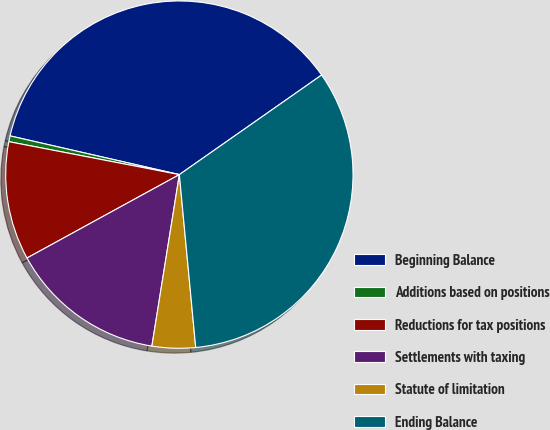Convert chart to OTSL. <chart><loc_0><loc_0><loc_500><loc_500><pie_chart><fcel>Beginning Balance<fcel>Additions based on positions<fcel>Reductions for tax positions<fcel>Settlements with taxing<fcel>Statute of limitation<fcel>Ending Balance<nl><fcel>36.7%<fcel>0.54%<fcel>11.01%<fcel>14.5%<fcel>4.03%<fcel>33.22%<nl></chart> 